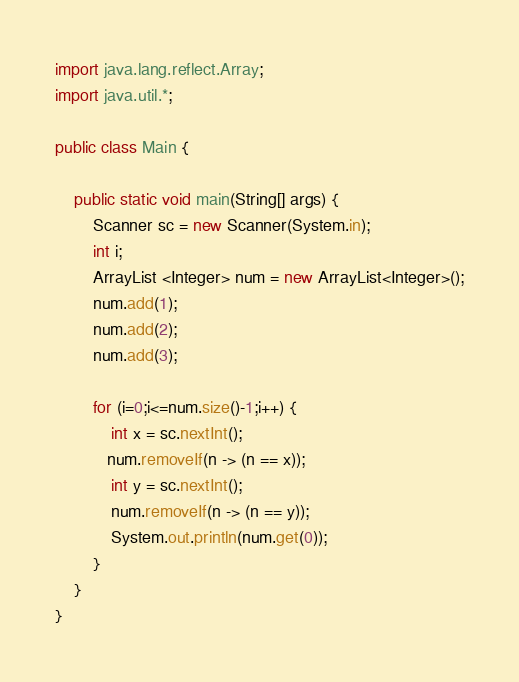Convert code to text. <code><loc_0><loc_0><loc_500><loc_500><_Java_>import java.lang.reflect.Array;
import java.util.*;

public class Main {

    public static void main(String[] args) {
        Scanner sc = new Scanner(System.in);
        int i;
        ArrayList <Integer> num = new ArrayList<Integer>();
        num.add(1);
        num.add(2);
        num.add(3);

        for (i=0;i<=num.size()-1;i++) {
            int x = sc.nextInt();
           num.removeIf(n -> (n == x));
            int y = sc.nextInt();
            num.removeIf(n -> (n == y));
            System.out.println(num.get(0));
        }
    }
}</code> 